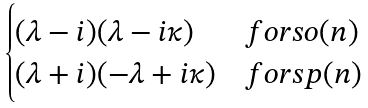Convert formula to latex. <formula><loc_0><loc_0><loc_500><loc_500>\begin{cases} ( \lambda - i ) ( \lambda - i \kappa ) & f o r s o ( n ) \\ ( \lambda + i ) ( - \lambda + i \kappa ) & f o r s p ( n ) \end{cases}</formula> 